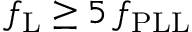Convert formula to latex. <formula><loc_0><loc_0><loc_500><loc_500>f _ { L } \geq 5 \, f _ { P L L }</formula> 